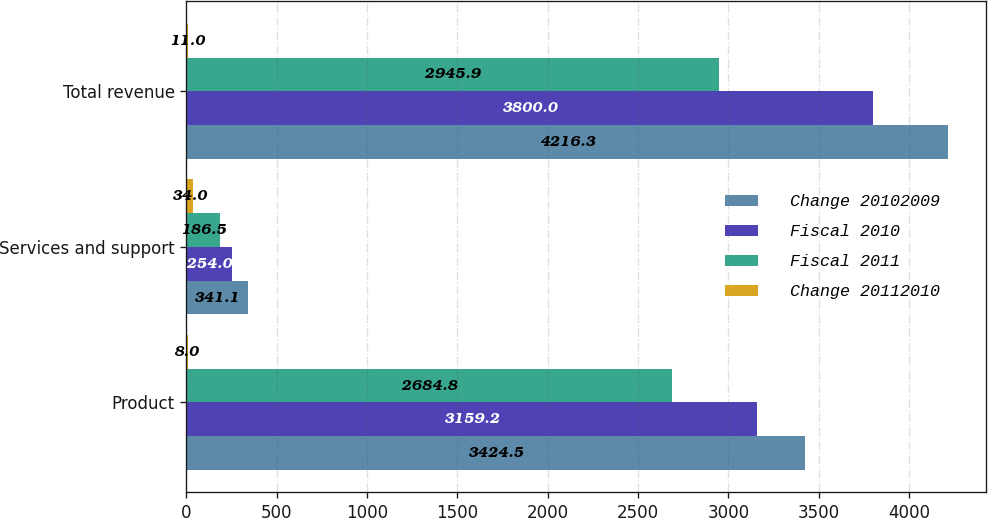Convert chart to OTSL. <chart><loc_0><loc_0><loc_500><loc_500><stacked_bar_chart><ecel><fcel>Product<fcel>Services and support<fcel>Total revenue<nl><fcel>Change 20102009<fcel>3424.5<fcel>341.1<fcel>4216.3<nl><fcel>Fiscal 2010<fcel>3159.2<fcel>254<fcel>3800<nl><fcel>Fiscal 2011<fcel>2684.8<fcel>186.5<fcel>2945.9<nl><fcel>Change 20112010<fcel>8<fcel>34<fcel>11<nl></chart> 